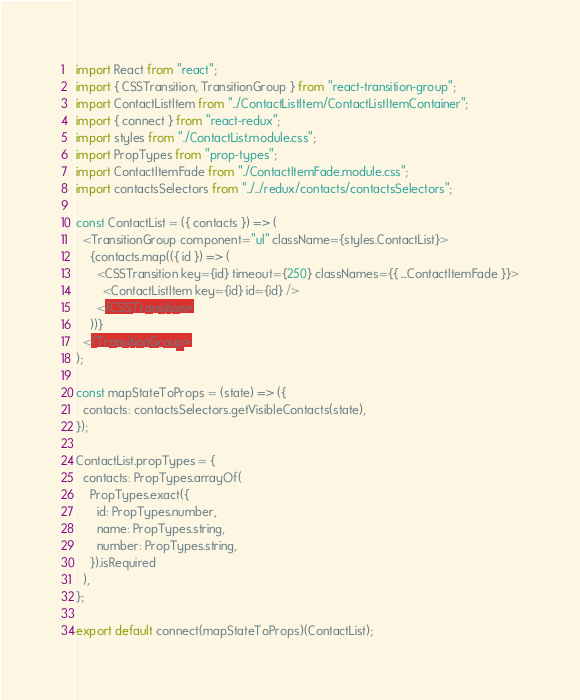Convert code to text. <code><loc_0><loc_0><loc_500><loc_500><_JavaScript_>import React from "react";
import { CSSTransition, TransitionGroup } from "react-transition-group";
import ContactListItem from "../ContactListItem/ContactListItemContainer";
import { connect } from "react-redux";
import styles from "./ContactList.module.css";
import PropTypes from "prop-types";
import ContactItemFade from "./ContactItemFade.module.css";
import contactsSelectors from "../../redux/contacts/contactsSelectors";

const ContactList = ({ contacts }) => (
  <TransitionGroup component="ul" className={styles.ContactList}>
    {contacts.map(({ id }) => (
      <CSSTransition key={id} timeout={250} classNames={{ ...ContactItemFade }}>
        <ContactListItem key={id} id={id} />
      </CSSTransition>
    ))}
  </TransitionGroup>
);

const mapStateToProps = (state) => ({
  contacts: contactsSelectors.getVisibleContacts(state),
});

ContactList.propTypes = {
  contacts: PropTypes.arrayOf(
    PropTypes.exact({
      id: PropTypes.number,
      name: PropTypes.string,
      number: PropTypes.string,
    }).isRequired
  ),
};

export default connect(mapStateToProps)(ContactList);
</code> 